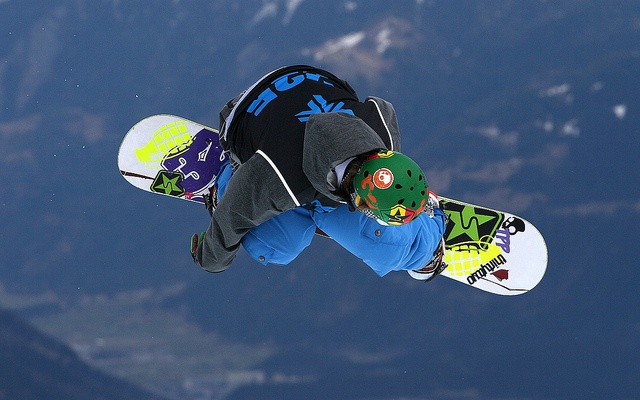Describe the objects in this image and their specific colors. I can see people in gray, black, and blue tones and snowboard in gray, lavender, black, navy, and yellow tones in this image. 